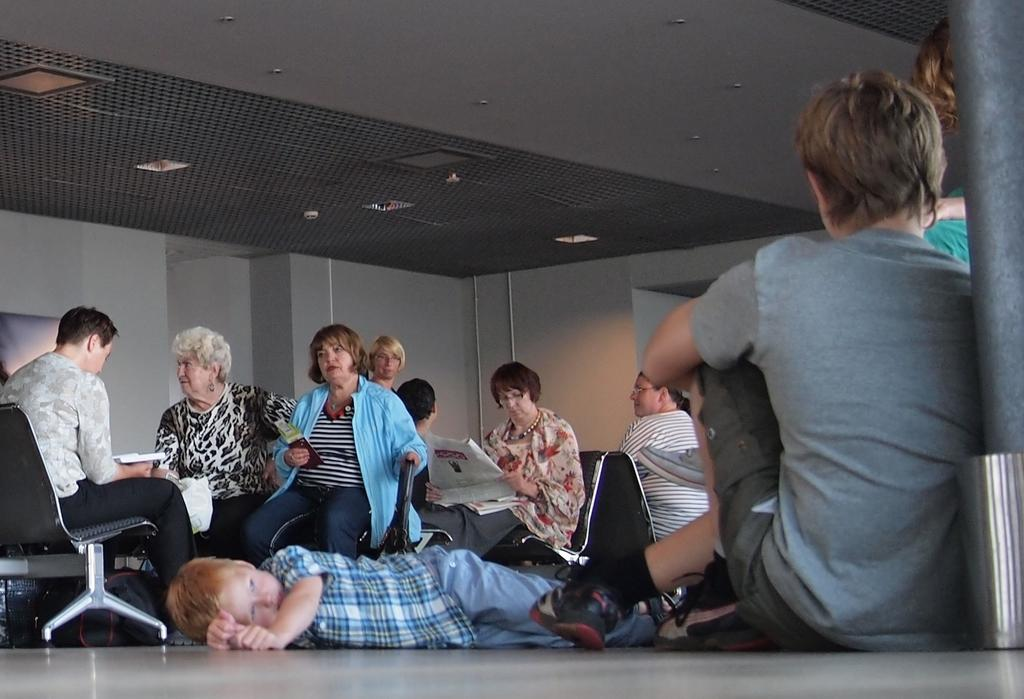What are the people in the image doing? There are people sitting on chairs and on the floor in the image. Some people are sleeping on the floor. Can you describe the seating arrangement in the image? Some people are sitting on chairs, while others are sitting or sleeping on the floor. What can be seen in the background of the image? There is a wall and a pipe visible in the background of the image. What type of glove is being used to take the picture in the image? There is no camera or glove present in the image; it only shows people sitting and sleeping on the floor, as well as a wall and a pipe in the background. 